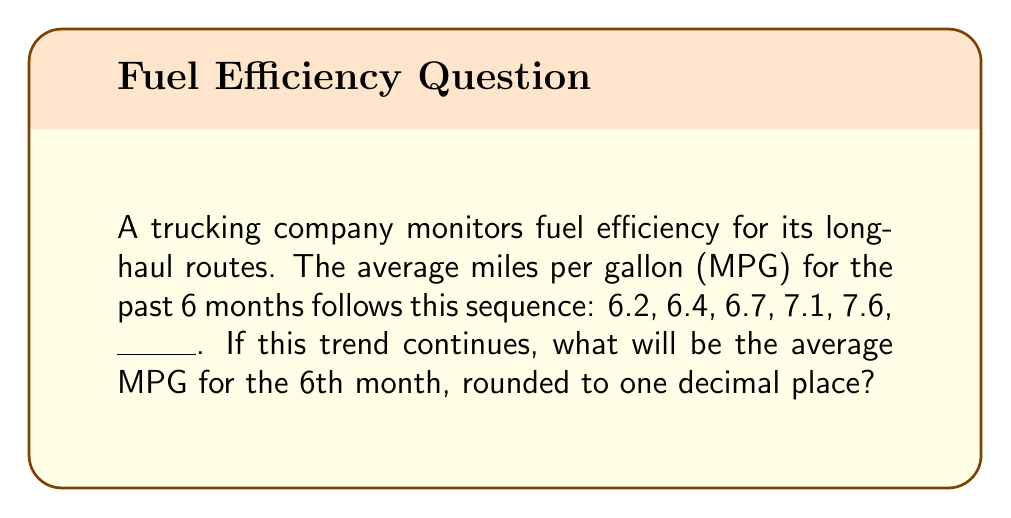Help me with this question. To solve this problem, we need to identify the pattern in the sequence and extend it to find the 6th term. Let's analyze the differences between consecutive terms:

1. From 6.2 to 6.4: Difference = 0.2
2. From 6.4 to 6.7: Difference = 0.3
3. From 6.7 to 7.1: Difference = 0.4
4. From 7.1 to 7.6: Difference = 0.5

We can see that the difference is increasing by 0.1 each time. This suggests an arithmetic sequence of second order.

The next difference should be: 0.5 + 0.1 = 0.6

Therefore, the 6th term should be:
$$ 7.6 + 0.6 = 8.2 $$

Rounding to one decimal place, the answer remains 8.2 MPG.

This increasing fuel efficiency trend is important for truckers as it can lead to significant cost savings and reduced environmental impact over long-haul routes.
Answer: 8.2 MPG 